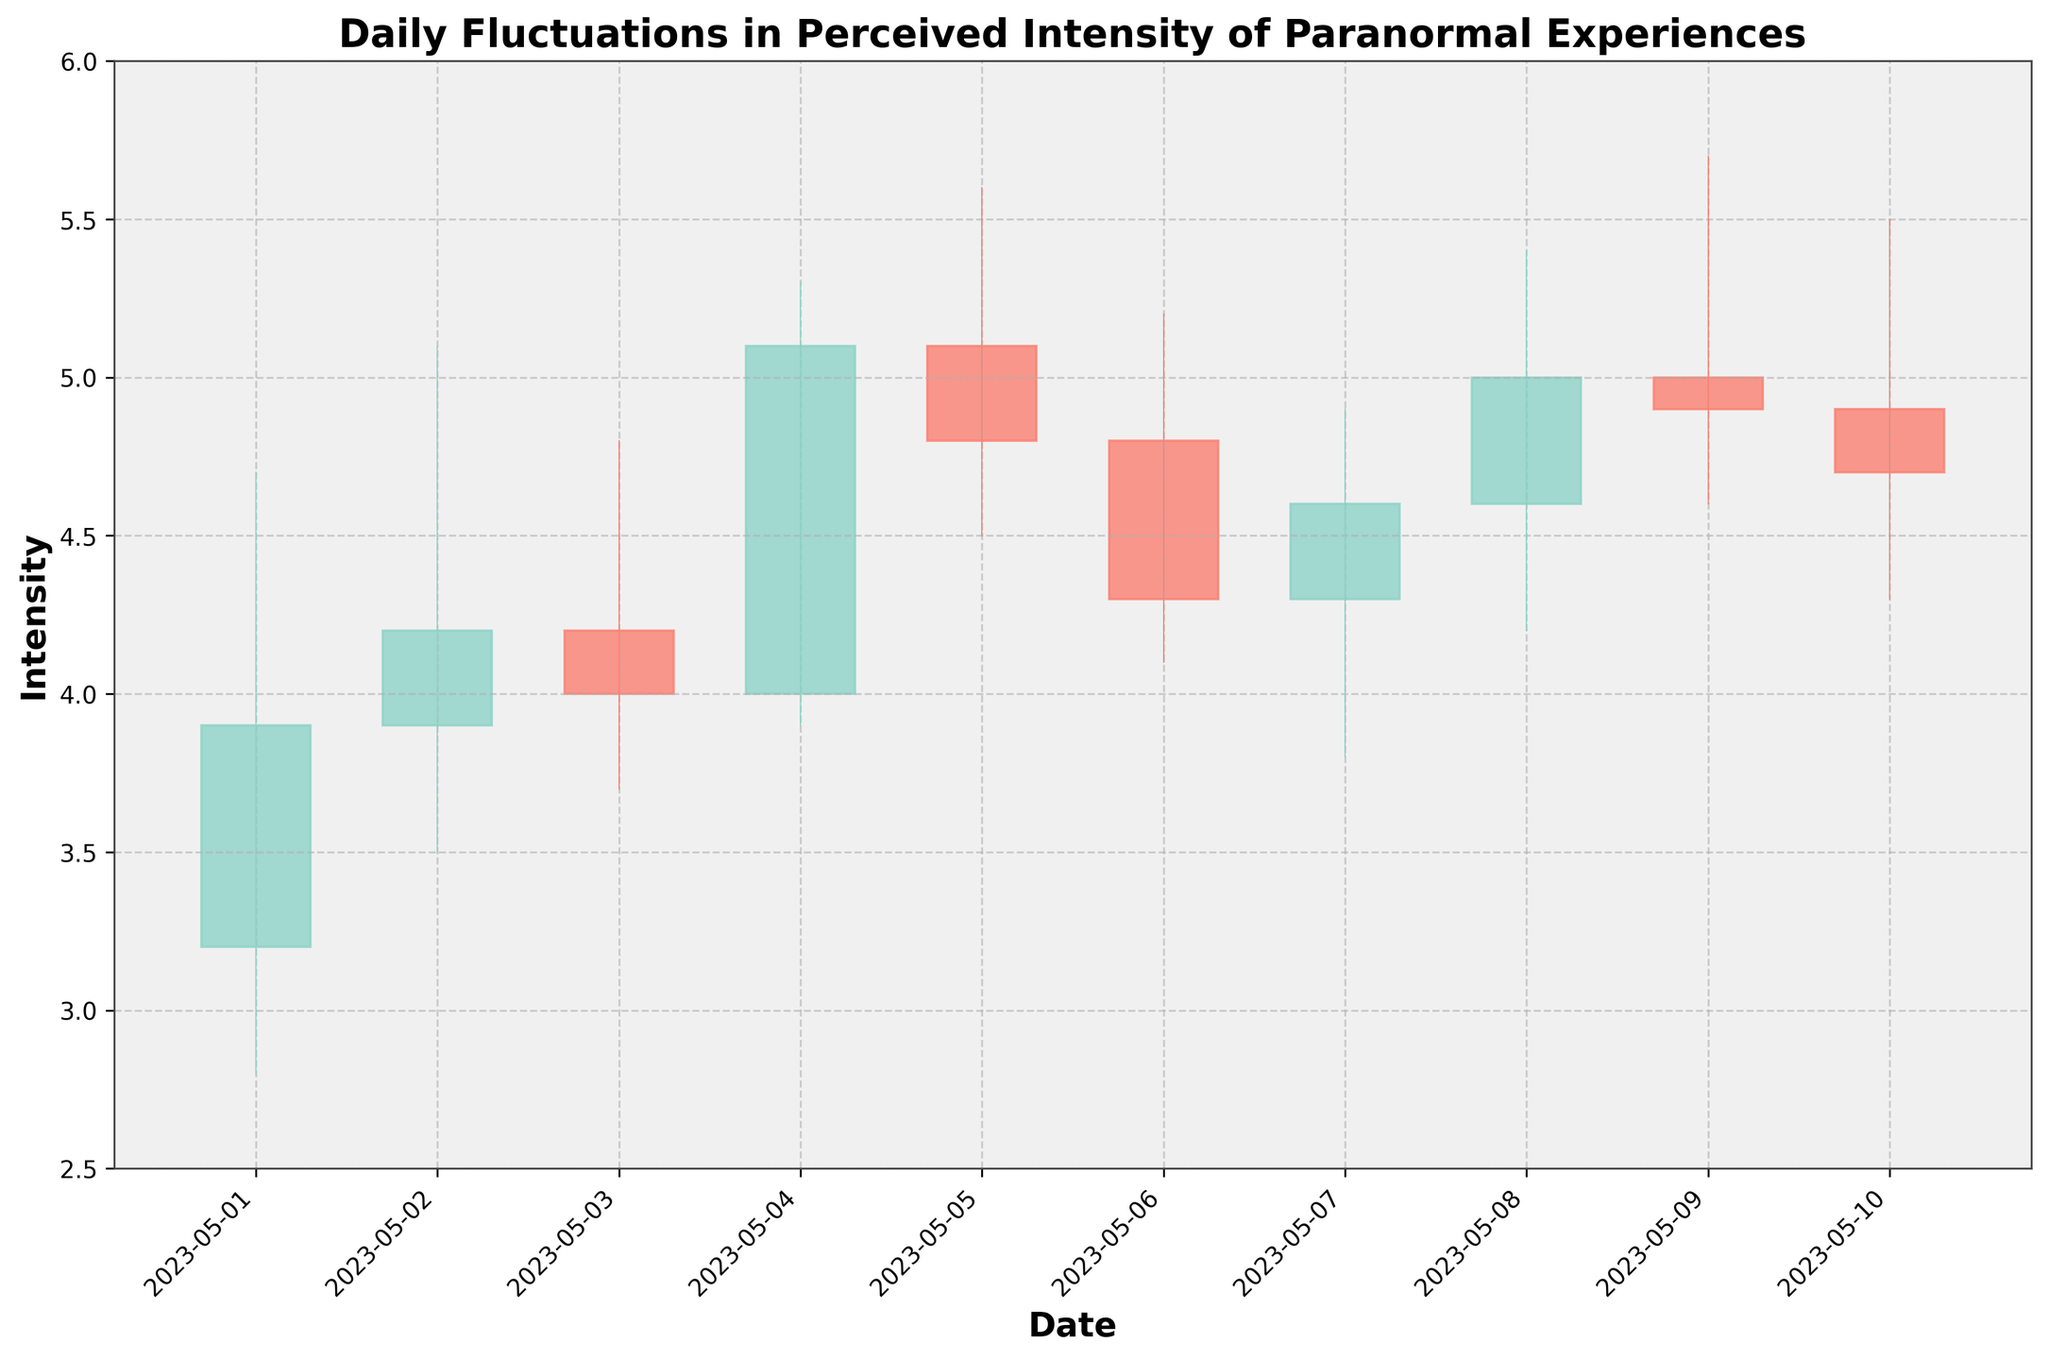What is the highest intensity recorded in this timeframe? To find the highest intensity, look at the peaks of the highest wicks in the OHLC chart. The highest recorded intensity is observed on May 09 with a value of 5.7.
Answer: 5.7 What is the overall trend of the closing intensity values from May 1 to May 10? To determine the trend, examine the closing values from May 1 to May 10. The closing values start at 3.9 on May 1 and end at 4.7 on May 10, showing an overall increase with fluctuations in between.
Answer: Increasing On which date was the largest daily fluctuation observed? Daily fluctuation is determined by the difference between the high and low values of each day. The largest fluctuation is recorded on May 04, with the high at 5.3 and the low at 3.9, resulting in a fluctuation of 1.4.
Answer: May 04 Which day had the smallest daily range in intensity? The daily range is the difference between the high and low values. The smallest range is observed on May 06, with a high of 5.2 and a low of 4.1, resulting in a range of 1.1.
Answer: May 06 What is the closing intensity on May 4, 2023? Look at the closing value on May 4, which is represented by the small horizontal dash on the right side of the candle for that day. The closing value on May 4 is 5.1.
Answer: 5.1 Comparing May 1 and May 10, on which date was the variance between high and low intensity higher? For May 1, the variance is 4.7 - 2.8 = 1.9. For May 10, the variance is 5.5 - 4.3 = 1.2. Therefore, May 1 had a higher variance.
Answer: May 1 What is the average closing intensity for the first five days of May? The closing values for the first five days are 3.9, 4.2, 4.0, 5.1, and 4.8. Calculate the average by summing these values and dividing by 5: (3.9 + 4.2 + 4.0 + 5.1 + 4.8) / 5 = 4.4.
Answer: 4.4 On which dates did the opening intensity equal the closing intensity? Check for days where the open and close values are the same. In this case, none of the dates have the same opening and closing intensity.
Answer: None How many days had a higher closing intensity than opening intensity? Count the number of days where the closing value is greater than the opening value. There are 4 days: May 04, May 07, May 08, and May 10.
Answer: 4 